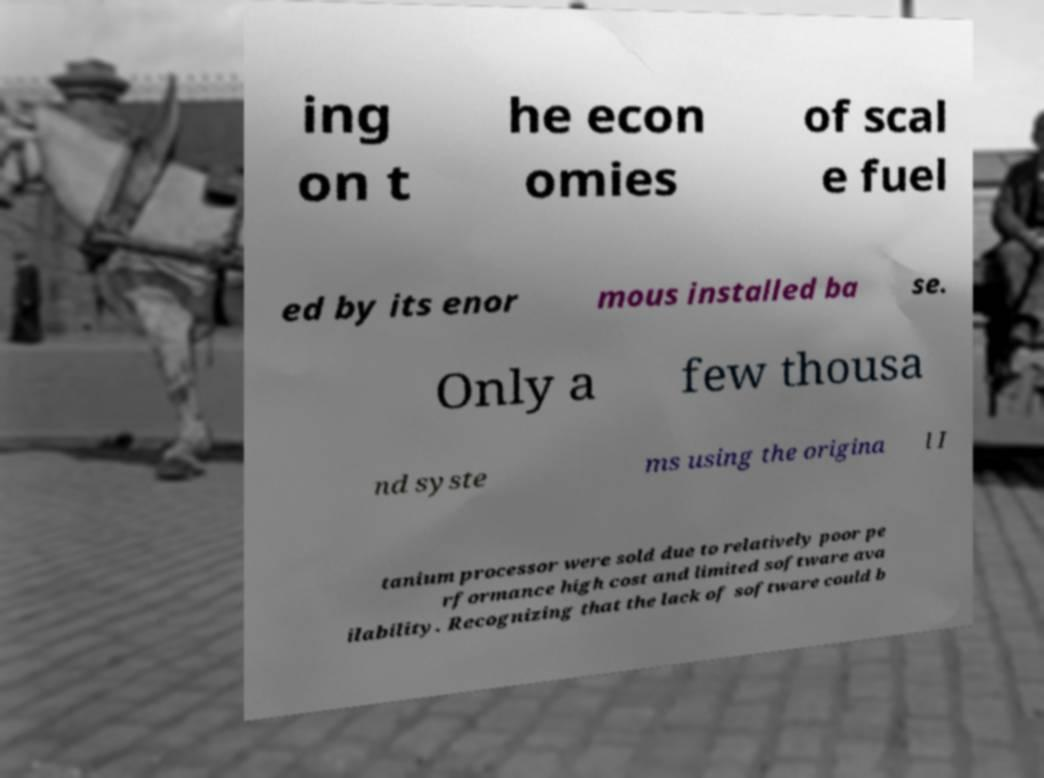Could you extract and type out the text from this image? ing on t he econ omies of scal e fuel ed by its enor mous installed ba se. Only a few thousa nd syste ms using the origina l I tanium processor were sold due to relatively poor pe rformance high cost and limited software ava ilability. Recognizing that the lack of software could b 